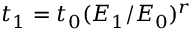Convert formula to latex. <formula><loc_0><loc_0><loc_500><loc_500>t _ { 1 } = t _ { 0 } ( E _ { 1 } / E _ { 0 } ) ^ { r }</formula> 